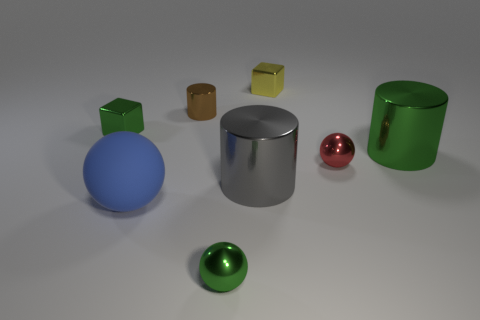Is there anything else that is the same material as the large sphere?
Your answer should be very brief. No. There is a yellow thing; are there any tiny metallic spheres on the left side of it?
Offer a very short reply. Yes. What is the size of the red sphere that is the same material as the big green cylinder?
Make the answer very short. Small. How many big yellow shiny objects are the same shape as the small brown object?
Keep it short and to the point. 0. Does the small yellow object have the same material as the green thing left of the small brown shiny object?
Provide a short and direct response. Yes. Are there more green things that are behind the small green shiny ball than tiny brown balls?
Your answer should be compact. Yes. Is there a brown cylinder that has the same material as the yellow cube?
Make the answer very short. Yes. Does the tiny green thing behind the red shiny sphere have the same material as the large thing to the left of the brown thing?
Give a very brief answer. No. Are there the same number of yellow shiny objects that are in front of the green cylinder and yellow metal things that are left of the small brown thing?
Make the answer very short. Yes. There is a sphere that is the same size as the green cylinder; what color is it?
Give a very brief answer. Blue. 